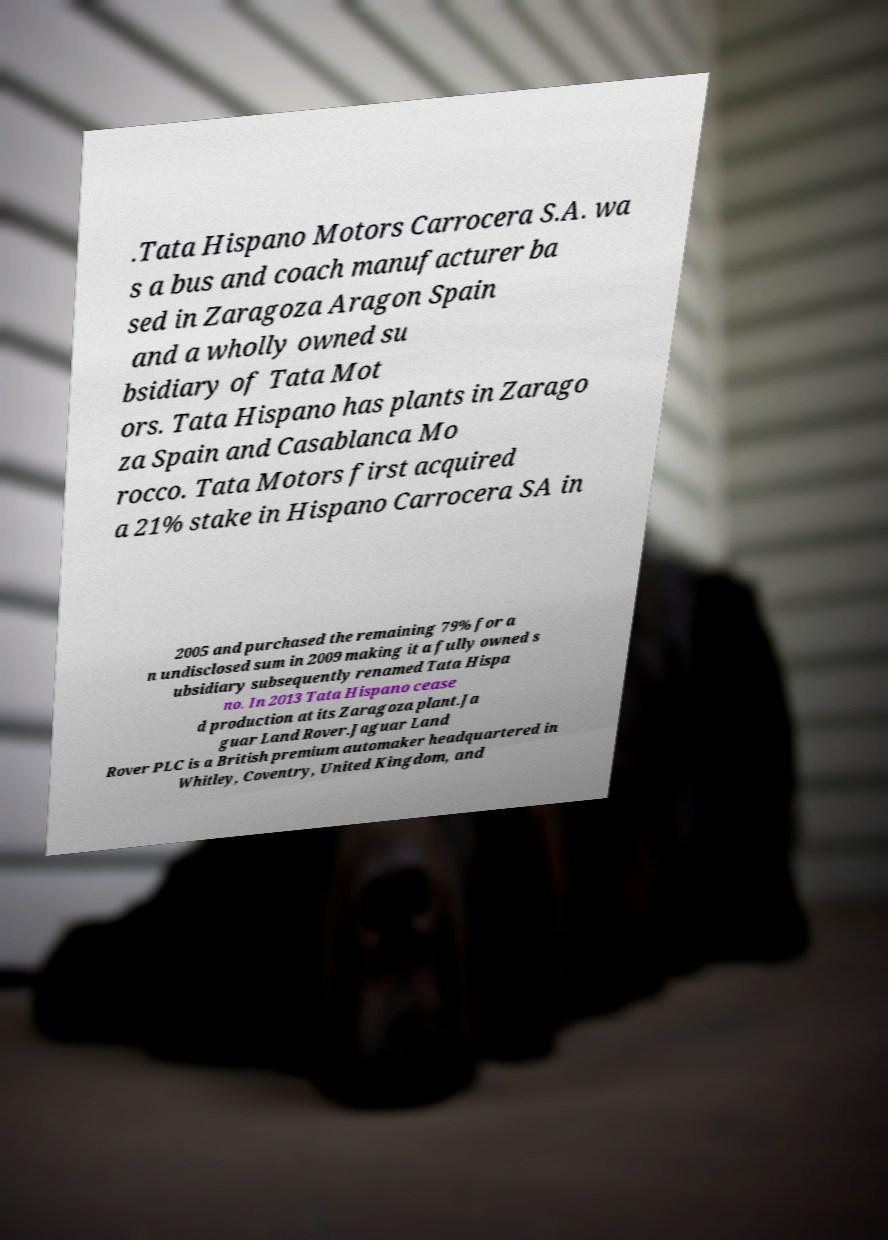Please read and relay the text visible in this image. What does it say? .Tata Hispano Motors Carrocera S.A. wa s a bus and coach manufacturer ba sed in Zaragoza Aragon Spain and a wholly owned su bsidiary of Tata Mot ors. Tata Hispano has plants in Zarago za Spain and Casablanca Mo rocco. Tata Motors first acquired a 21% stake in Hispano Carrocera SA in 2005 and purchased the remaining 79% for a n undisclosed sum in 2009 making it a fully owned s ubsidiary subsequently renamed Tata Hispa no. In 2013 Tata Hispano cease d production at its Zaragoza plant.Ja guar Land Rover.Jaguar Land Rover PLC is a British premium automaker headquartered in Whitley, Coventry, United Kingdom, and 